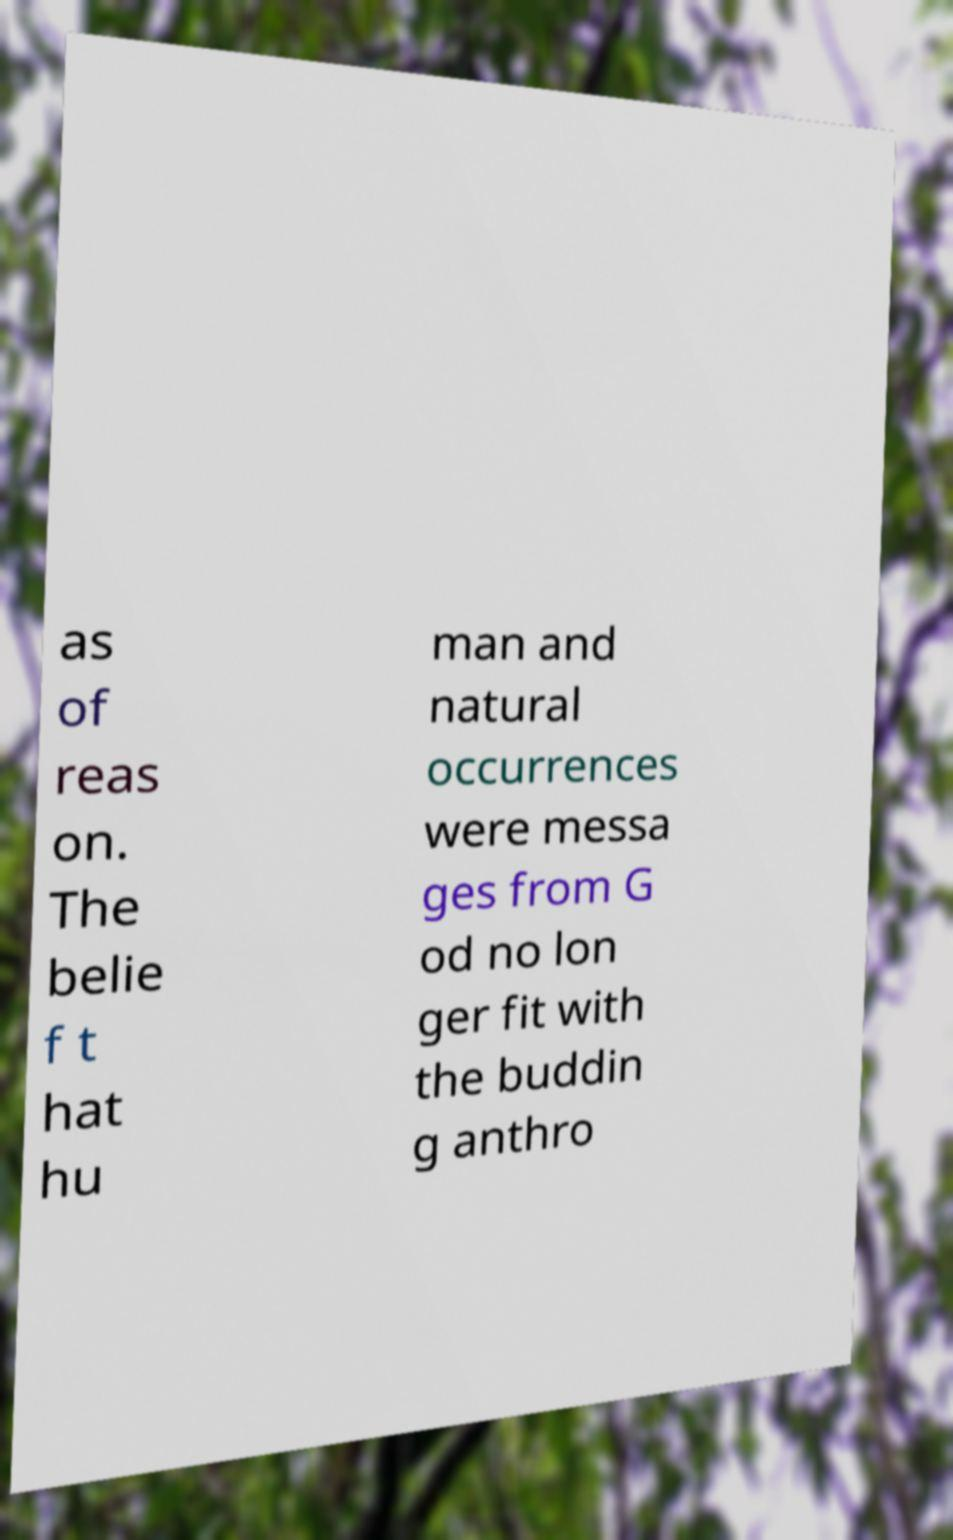There's text embedded in this image that I need extracted. Can you transcribe it verbatim? as of reas on. The belie f t hat hu man and natural occurrences were messa ges from G od no lon ger fit with the buddin g anthro 